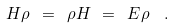<formula> <loc_0><loc_0><loc_500><loc_500>H \rho \ = \ \rho H \ = \ E \rho \ \ .</formula> 